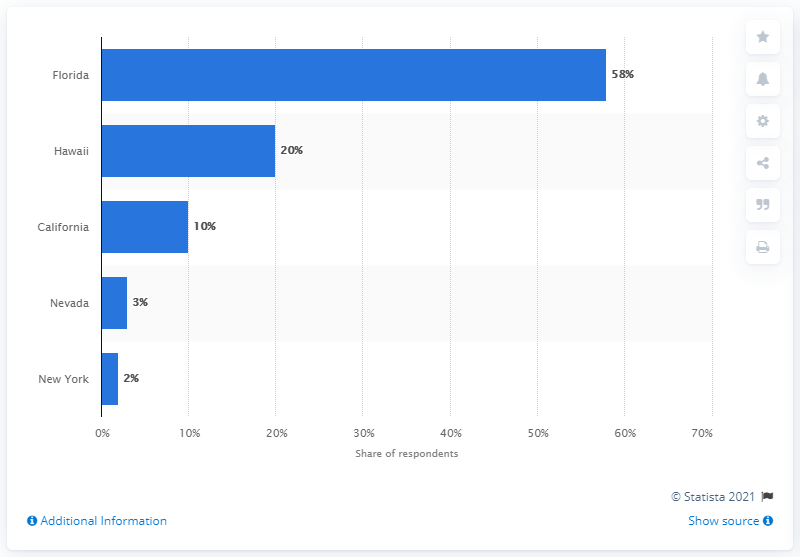Point out several critical features in this image. In 2014, Florida was the most popular winter domestic destination for travelers. 